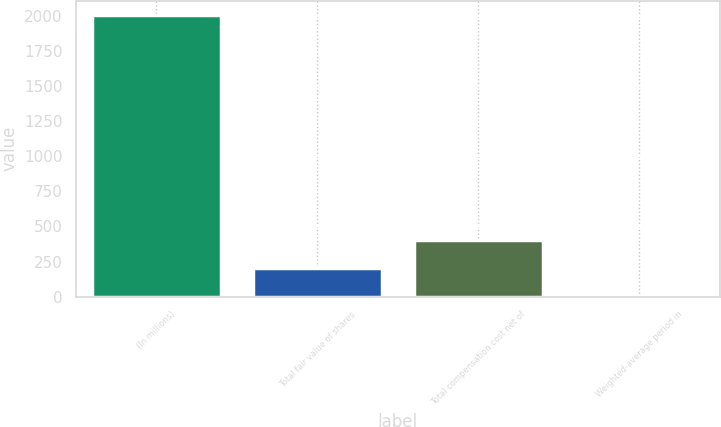<chart> <loc_0><loc_0><loc_500><loc_500><bar_chart><fcel>(In millions)<fcel>Total fair value of shares<fcel>Total compensation cost net of<fcel>Weighted-average period in<nl><fcel>2006<fcel>203.3<fcel>403.6<fcel>3<nl></chart> 